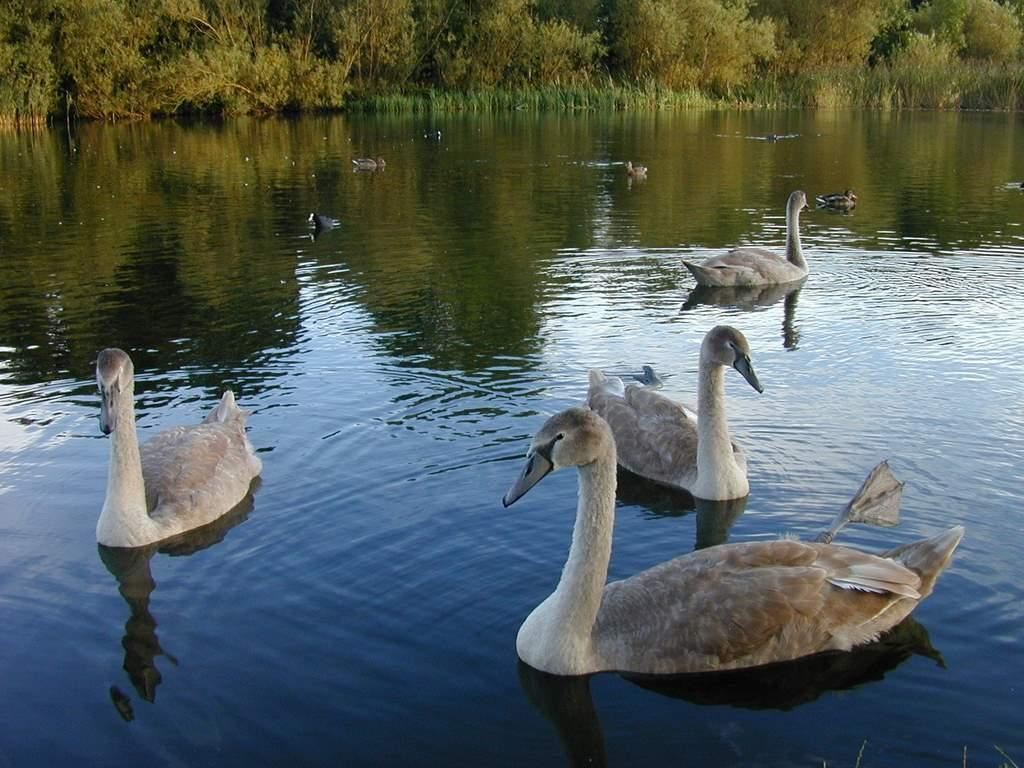What type of animals can be seen in the image? Birds can be seen in the image. What type of vegetation is present in the image? There are trees and plants in the image. What is the primary element visible in the image? Water is visible in the image. What can be observed in the water's reflection? The water has a reflection of the trees. What type of drug can be seen in the image? There is no drug present in the image; it features birds, trees, plants, and water. Are there any signs of extraterrestrial life in the image? There is no indication of extraterrestrial life or space-related elements in the image. 